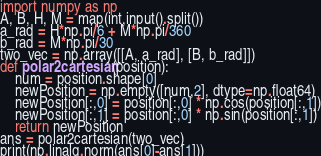<code> <loc_0><loc_0><loc_500><loc_500><_Python_>import numpy as np
A, B, H, M = map(int,input().split())
a_rad = H*np.pi/6 + M*np.pi/360
b_rad = M*np.pi/30
two_vec = np.array([[A, a_rad], [B, b_rad]])
def polar2cartesian(position):
    num = position.shape[0]
    newPosition = np.empty([num,2], dtype=np.float64)
    newPosition[:,0] = position[:,0] * np.cos(position[:,1])
    newPosition[:,1] = position[:,0] * np.sin(position[:,1])
    return newPosition
ans = polar2cartesian(two_vec)
print(np.linalg.norm(ans[0]-ans[1]))</code> 